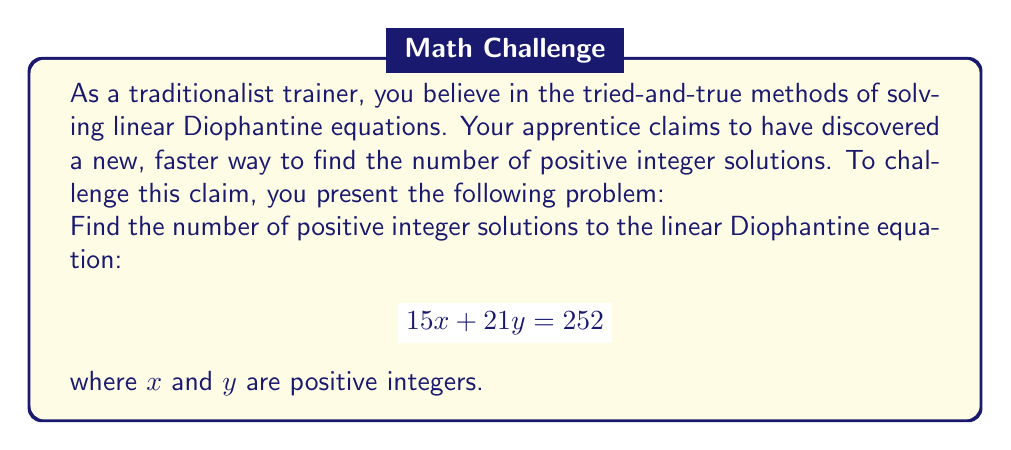Provide a solution to this math problem. Let's solve this using the traditional method:

1) First, we need to find the greatest common divisor (GCD) of the coefficients:
   $\gcd(15, 21) = 3$

2) Check if the GCD divides the constant term:
   $3 | 252$ (252 is divisible by 3), so solutions exist.

3) Divide the equation by the GCD:
   $$ 5x + 7y = 84 $$

4) Find a particular solution using the Euclidean algorithm:
   $84 = 5 \cdot 16 + 4$
   $5 = 1 \cdot 4 + 1$
   $4 = 4 \cdot 1 + 0$
   
   Working backwards:
   $1 = 5 - 1 \cdot 4$
   $1 = 5 - 1 \cdot (84 - 5 \cdot 16) = 17 \cdot 5 - 1 \cdot 84$
   
   Multiplying by 84:
   $84 = 1428 \cdot 5 - 84 \cdot 84$
   
   So, a particular solution is $(x_0, y_0) = (1428, -84)$

5) The general solution is:
   $$ x = 1428 - 7t $$
   $$ y = -84 + 5t $$
   where $t$ is an integer.

6) To find positive integer solutions, we need:
   $1428 - 7t > 0$ and $-84 + 5t > 0$
   
   $t < 204$ and $t > 16.8$

7) The integer values of $t$ that satisfy both conditions are 17 to 203.

8) The number of such integers is $203 - 17 + 1 = 187$.
Answer: There are 187 positive integer solutions to the given linear Diophantine equation. 